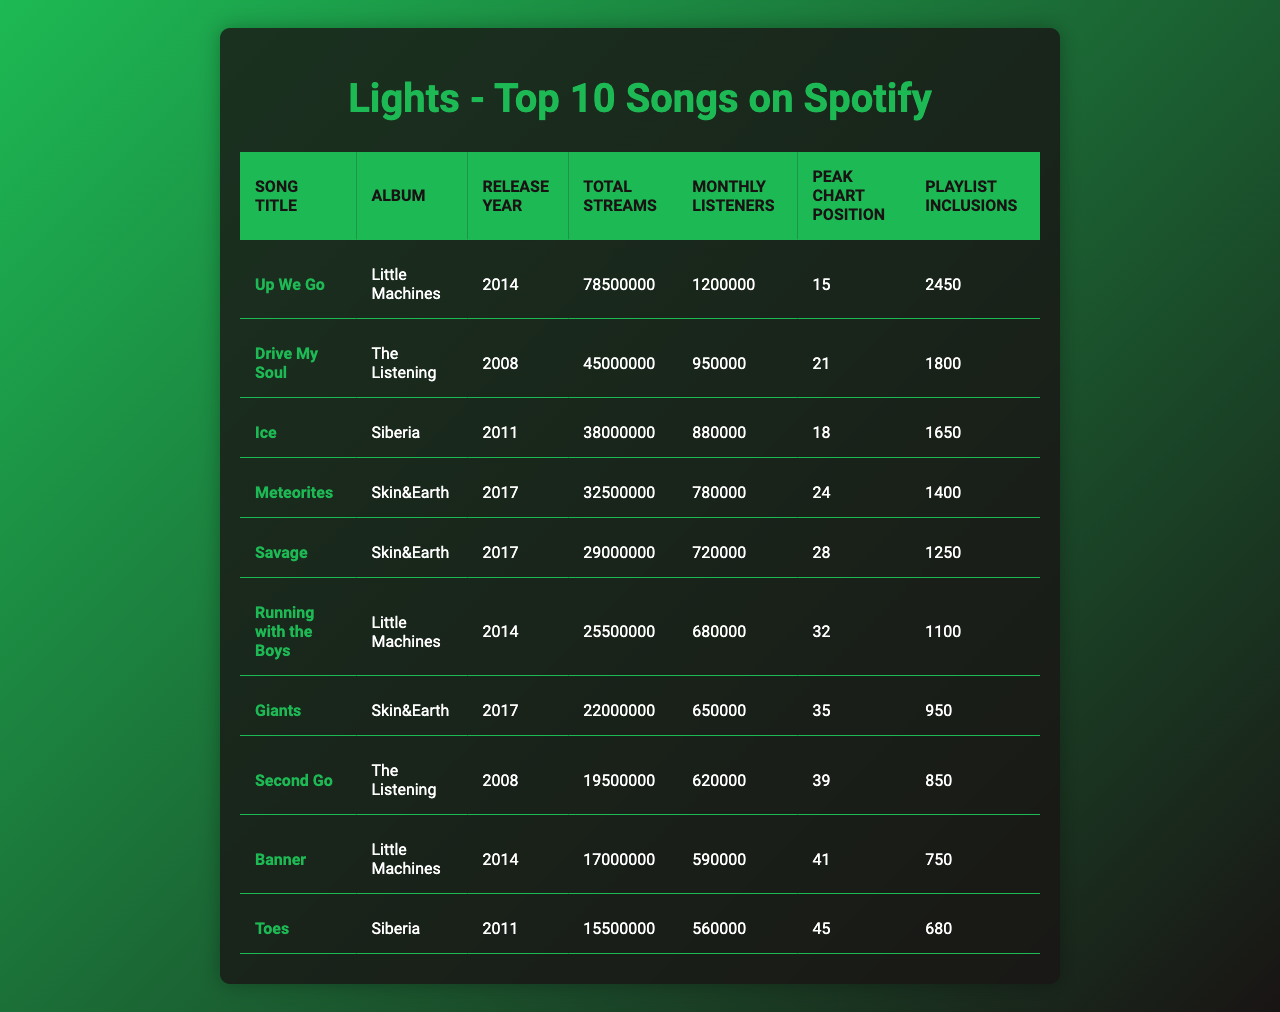What is the total number of streams for "Up We Go"? The table shows that the total streams for "Up We Go" is listed as 78,500,000.
Answer: 78,500,000 Which song has the highest number of monthly listeners? In the table, "Up We Go" has the highest monthly listeners at 1,200,000.
Answer: "Up We Go" What is the peak chart position of "Giants"? The table indicates that "Giants" reached a peak chart position of 35.
Answer: 35 How many songs have more than 30 million total streams? By examining the total streams column, we find that there are 5 songs with more than 30 million streams: "Up We Go," "Drive My Soul," "Ice," "Meteorites," and "Savage."
Answer: 5 What is the average peak chart position of the top 10 songs? Total peak chart positions are: 15 + 21 + 18 + 24 + 28 + 32 + 35 + 39 + 41 + 45 =  284. There are 10 songs, so the average is 284 / 10 = 28.4, which can be rounded to 28.
Answer: 28 Is "Savage" included in more playlists than "Toes"? The table shows that "Savage" has 1,250 playlist inclusions while "Toes" has 680. Therefore, "Savage" is included in more playlists.
Answer: Yes Which album has the most songs in the top 10? By reviewing the album column, "Little Machines" has 3 songs: "Up We Go," "Running with the Boys," and "Banner," which is more than any other album.
Answer: Little Machines What is the combined total streams of all songs from the album "Skin&Earth"? The total streams for the songs from "Skin&Earth" are: "Meteorites" (32,500,000) + "Savage" (29,000,000) + "Giants" (22,000,000) = 83,500,000.
Answer: 83,500,000 Does "Drive My Soul" have more monthly listeners than "Second Go"? The table shows "Drive My Soul" has 950,000 monthly listeners, while "Second Go" has 620,000. Hence, "Drive My Soul" has more.
Answer: Yes What percentage of the total streams of the top 10 songs come from "Ice"? The total streams of "Ice" are 38,000,000 and the combined total streams of all songs are 285,500,000. Calculating the percentage: (38,000,000 / 285,500,000) * 100 = 13.3%.
Answer: 13.3% 